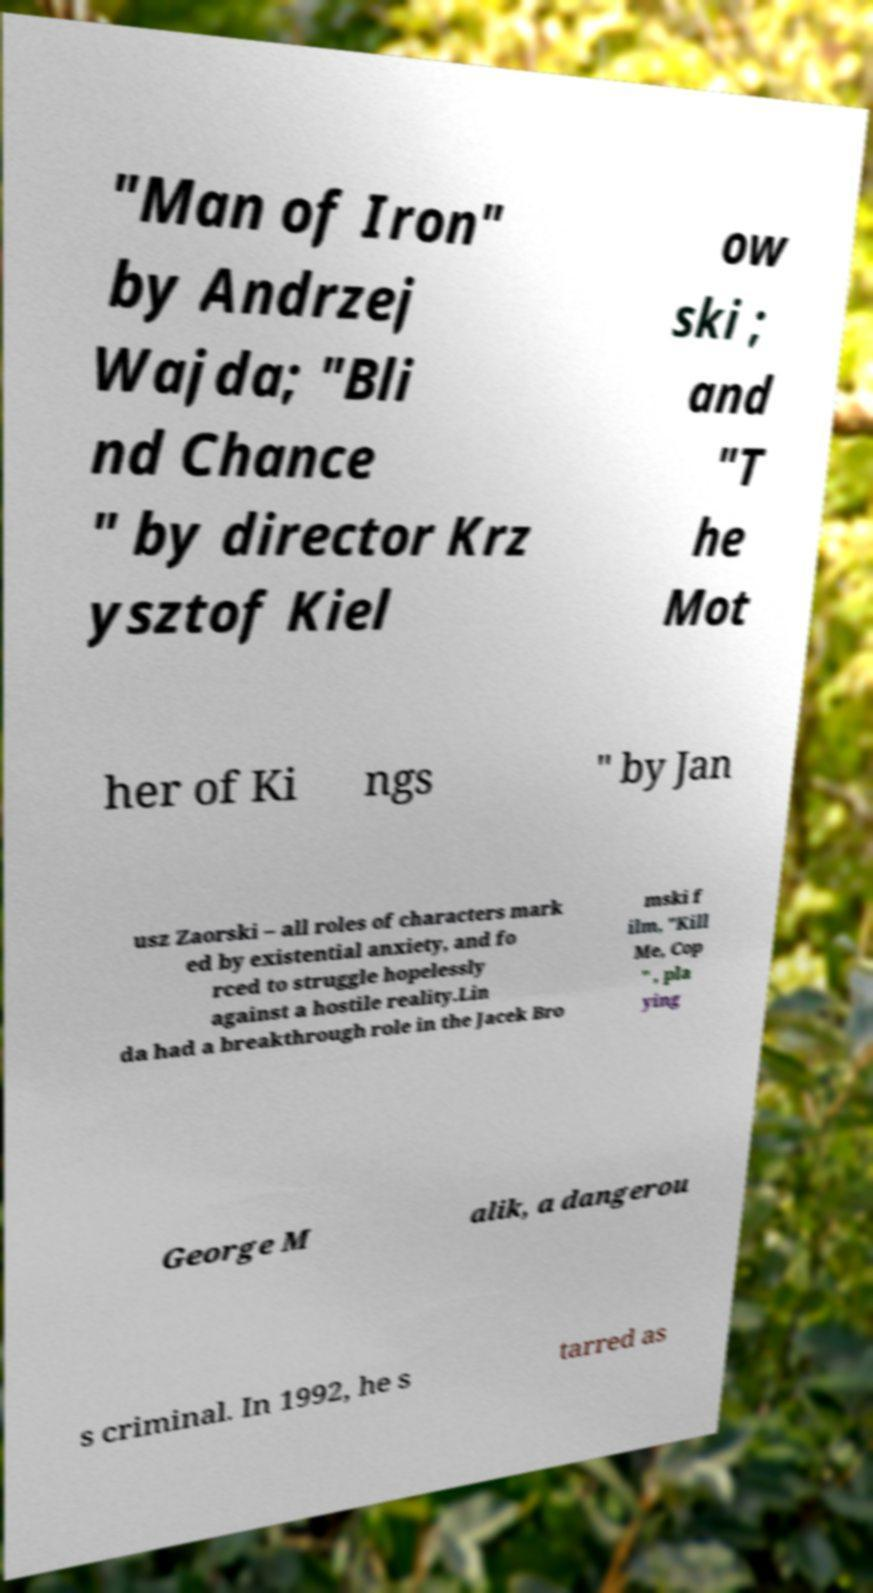I need the written content from this picture converted into text. Can you do that? "Man of Iron" by Andrzej Wajda; "Bli nd Chance " by director Krz ysztof Kiel ow ski ; and "T he Mot her of Ki ngs " by Jan usz Zaorski – all roles of characters mark ed by existential anxiety, and fo rced to struggle hopelessly against a hostile reality.Lin da had a breakthrough role in the Jacek Bro mski f ilm, "Kill Me, Cop " , pla ying George M alik, a dangerou s criminal. In 1992, he s tarred as 